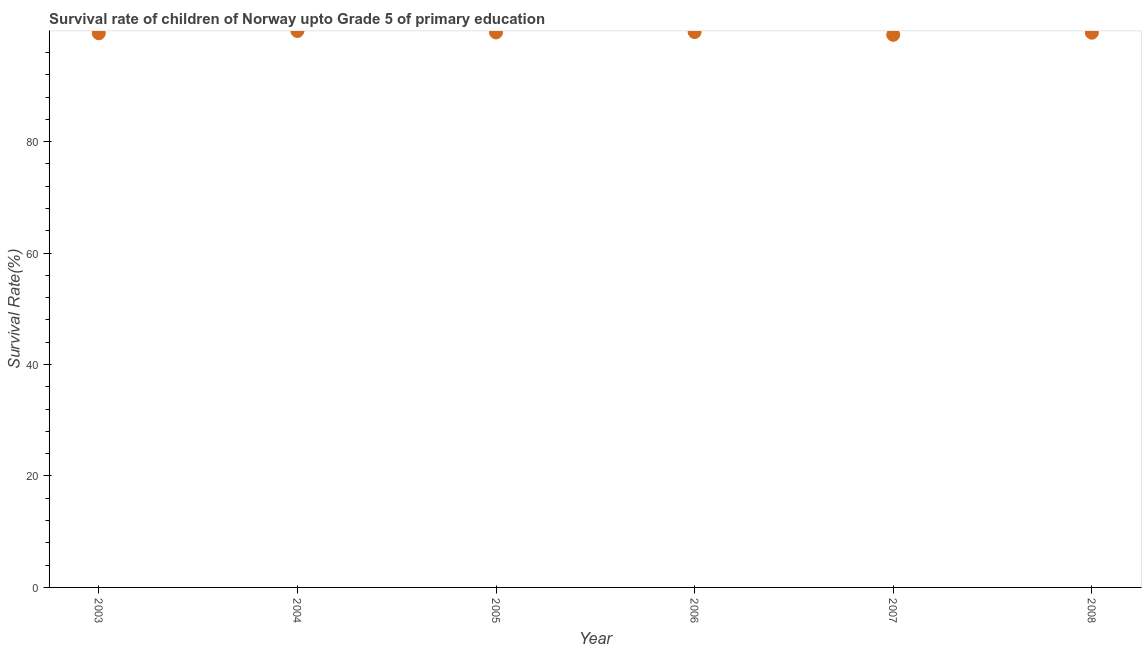What is the survival rate in 2005?
Offer a terse response. 99.59. Across all years, what is the maximum survival rate?
Provide a short and direct response. 99.85. Across all years, what is the minimum survival rate?
Keep it short and to the point. 99.17. In which year was the survival rate maximum?
Offer a very short reply. 2004. In which year was the survival rate minimum?
Provide a short and direct response. 2007. What is the sum of the survival rate?
Keep it short and to the point. 597.27. What is the difference between the survival rate in 2004 and 2005?
Your answer should be compact. 0.26. What is the average survival rate per year?
Make the answer very short. 99.55. What is the median survival rate?
Offer a terse response. 99.57. Do a majority of the years between 2007 and 2005 (inclusive) have survival rate greater than 36 %?
Your response must be concise. No. What is the ratio of the survival rate in 2005 to that in 2006?
Give a very brief answer. 1. Is the survival rate in 2005 less than that in 2008?
Provide a short and direct response. No. Is the difference between the survival rate in 2006 and 2008 greater than the difference between any two years?
Give a very brief answer. No. What is the difference between the highest and the second highest survival rate?
Give a very brief answer. 0.19. What is the difference between the highest and the lowest survival rate?
Offer a terse response. 0.68. Does the survival rate monotonically increase over the years?
Provide a succinct answer. No. How many dotlines are there?
Give a very brief answer. 1. Does the graph contain any zero values?
Your answer should be compact. No. Does the graph contain grids?
Offer a terse response. No. What is the title of the graph?
Provide a succinct answer. Survival rate of children of Norway upto Grade 5 of primary education. What is the label or title of the Y-axis?
Offer a very short reply. Survival Rate(%). What is the Survival Rate(%) in 2003?
Provide a short and direct response. 99.44. What is the Survival Rate(%) in 2004?
Offer a very short reply. 99.85. What is the Survival Rate(%) in 2005?
Make the answer very short. 99.59. What is the Survival Rate(%) in 2006?
Provide a succinct answer. 99.67. What is the Survival Rate(%) in 2007?
Offer a terse response. 99.17. What is the Survival Rate(%) in 2008?
Your response must be concise. 99.55. What is the difference between the Survival Rate(%) in 2003 and 2004?
Provide a short and direct response. -0.41. What is the difference between the Survival Rate(%) in 2003 and 2005?
Offer a terse response. -0.15. What is the difference between the Survival Rate(%) in 2003 and 2006?
Make the answer very short. -0.22. What is the difference between the Survival Rate(%) in 2003 and 2007?
Your answer should be very brief. 0.27. What is the difference between the Survival Rate(%) in 2003 and 2008?
Ensure brevity in your answer.  -0.1. What is the difference between the Survival Rate(%) in 2004 and 2005?
Give a very brief answer. 0.26. What is the difference between the Survival Rate(%) in 2004 and 2006?
Ensure brevity in your answer.  0.19. What is the difference between the Survival Rate(%) in 2004 and 2007?
Give a very brief answer. 0.68. What is the difference between the Survival Rate(%) in 2004 and 2008?
Your answer should be very brief. 0.3. What is the difference between the Survival Rate(%) in 2005 and 2006?
Your answer should be compact. -0.08. What is the difference between the Survival Rate(%) in 2005 and 2007?
Give a very brief answer. 0.42. What is the difference between the Survival Rate(%) in 2005 and 2008?
Your answer should be compact. 0.04. What is the difference between the Survival Rate(%) in 2006 and 2007?
Make the answer very short. 0.5. What is the difference between the Survival Rate(%) in 2006 and 2008?
Your response must be concise. 0.12. What is the difference between the Survival Rate(%) in 2007 and 2008?
Make the answer very short. -0.38. What is the ratio of the Survival Rate(%) in 2003 to that in 2005?
Your response must be concise. 1. What is the ratio of the Survival Rate(%) in 2003 to that in 2007?
Offer a terse response. 1. What is the ratio of the Survival Rate(%) in 2004 to that in 2005?
Keep it short and to the point. 1. What is the ratio of the Survival Rate(%) in 2004 to that in 2006?
Your answer should be very brief. 1. What is the ratio of the Survival Rate(%) in 2004 to that in 2007?
Offer a terse response. 1.01. What is the ratio of the Survival Rate(%) in 2005 to that in 2006?
Your answer should be compact. 1. What is the ratio of the Survival Rate(%) in 2005 to that in 2007?
Offer a very short reply. 1. What is the ratio of the Survival Rate(%) in 2006 to that in 2007?
Provide a succinct answer. 1. What is the ratio of the Survival Rate(%) in 2006 to that in 2008?
Your response must be concise. 1. What is the ratio of the Survival Rate(%) in 2007 to that in 2008?
Provide a short and direct response. 1. 